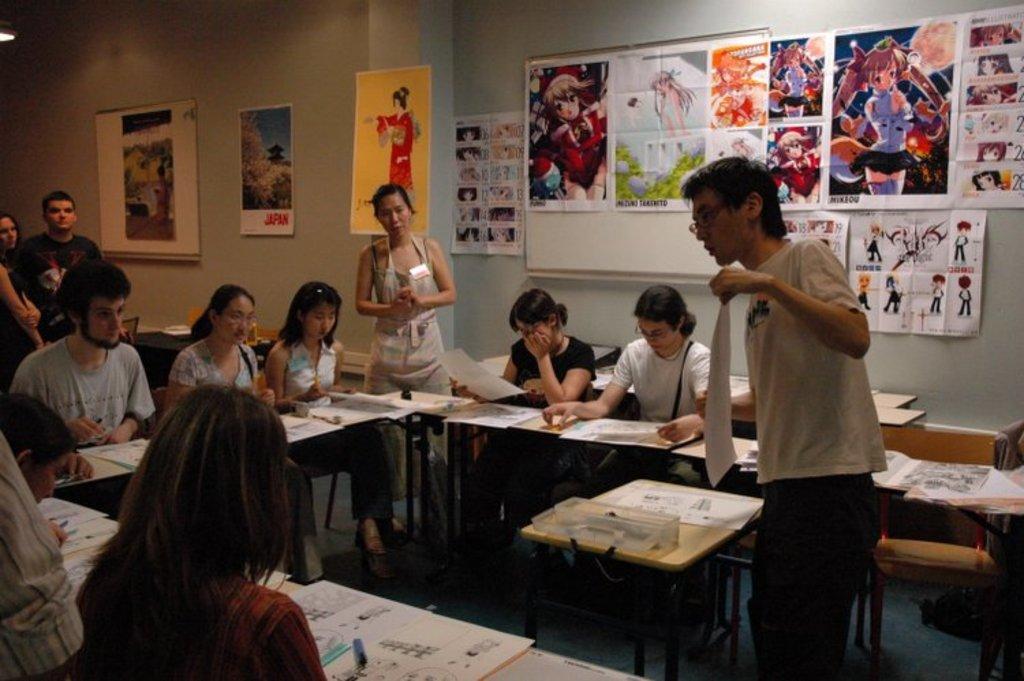How would you summarize this image in a sentence or two? There are group of persons sitting on chairs and there is a table in front of them which has some papers on it and there is a person holding a paper is standing in front of them and there are pictures which are attached to wall in the background. 